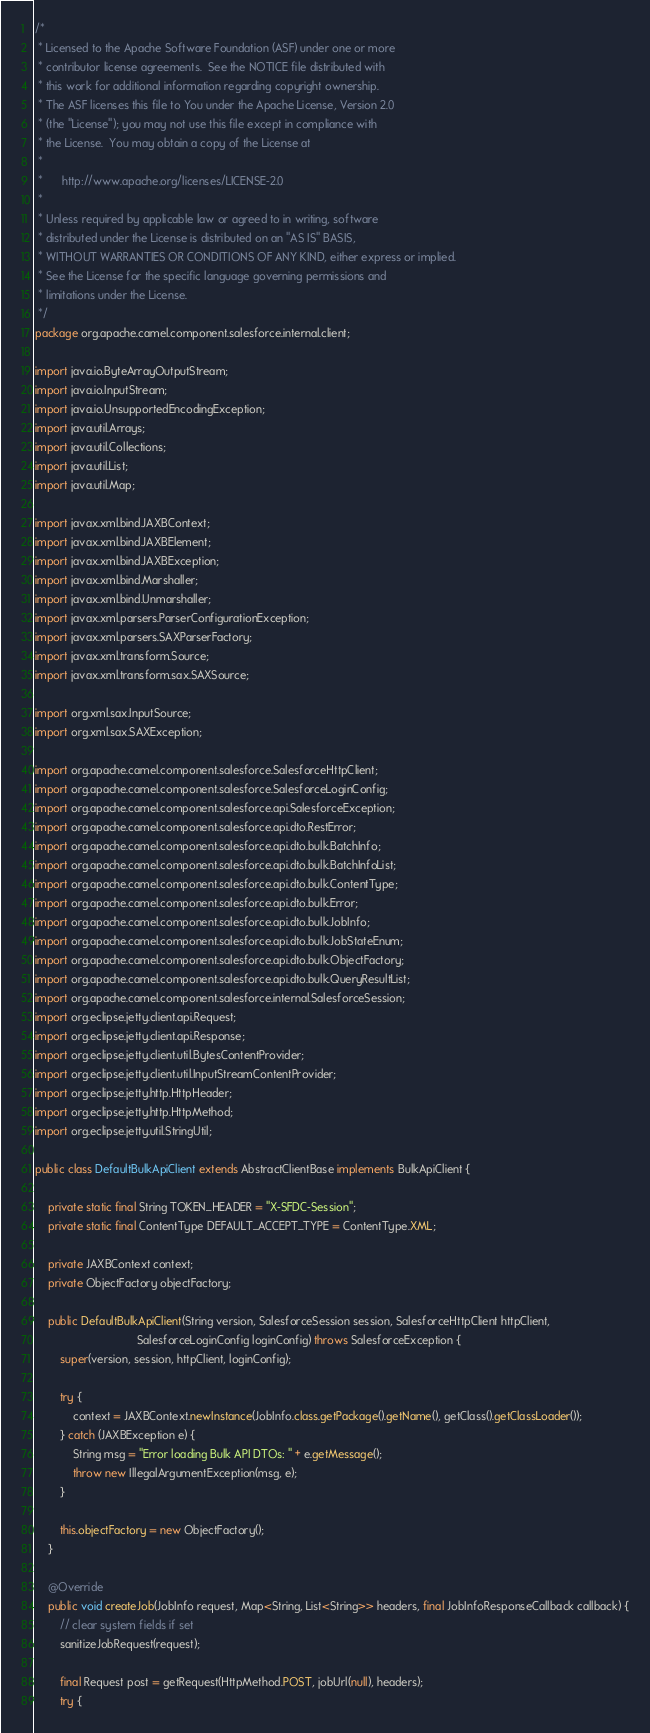<code> <loc_0><loc_0><loc_500><loc_500><_Java_>/*
 * Licensed to the Apache Software Foundation (ASF) under one or more
 * contributor license agreements.  See the NOTICE file distributed with
 * this work for additional information regarding copyright ownership.
 * The ASF licenses this file to You under the Apache License, Version 2.0
 * (the "License"); you may not use this file except in compliance with
 * the License.  You may obtain a copy of the License at
 *
 *      http://www.apache.org/licenses/LICENSE-2.0
 *
 * Unless required by applicable law or agreed to in writing, software
 * distributed under the License is distributed on an "AS IS" BASIS,
 * WITHOUT WARRANTIES OR CONDITIONS OF ANY KIND, either express or implied.
 * See the License for the specific language governing permissions and
 * limitations under the License.
 */
package org.apache.camel.component.salesforce.internal.client;

import java.io.ByteArrayOutputStream;
import java.io.InputStream;
import java.io.UnsupportedEncodingException;
import java.util.Arrays;
import java.util.Collections;
import java.util.List;
import java.util.Map;

import javax.xml.bind.JAXBContext;
import javax.xml.bind.JAXBElement;
import javax.xml.bind.JAXBException;
import javax.xml.bind.Marshaller;
import javax.xml.bind.Unmarshaller;
import javax.xml.parsers.ParserConfigurationException;
import javax.xml.parsers.SAXParserFactory;
import javax.xml.transform.Source;
import javax.xml.transform.sax.SAXSource;

import org.xml.sax.InputSource;
import org.xml.sax.SAXException;

import org.apache.camel.component.salesforce.SalesforceHttpClient;
import org.apache.camel.component.salesforce.SalesforceLoginConfig;
import org.apache.camel.component.salesforce.api.SalesforceException;
import org.apache.camel.component.salesforce.api.dto.RestError;
import org.apache.camel.component.salesforce.api.dto.bulk.BatchInfo;
import org.apache.camel.component.salesforce.api.dto.bulk.BatchInfoList;
import org.apache.camel.component.salesforce.api.dto.bulk.ContentType;
import org.apache.camel.component.salesforce.api.dto.bulk.Error;
import org.apache.camel.component.salesforce.api.dto.bulk.JobInfo;
import org.apache.camel.component.salesforce.api.dto.bulk.JobStateEnum;
import org.apache.camel.component.salesforce.api.dto.bulk.ObjectFactory;
import org.apache.camel.component.salesforce.api.dto.bulk.QueryResultList;
import org.apache.camel.component.salesforce.internal.SalesforceSession;
import org.eclipse.jetty.client.api.Request;
import org.eclipse.jetty.client.api.Response;
import org.eclipse.jetty.client.util.BytesContentProvider;
import org.eclipse.jetty.client.util.InputStreamContentProvider;
import org.eclipse.jetty.http.HttpHeader;
import org.eclipse.jetty.http.HttpMethod;
import org.eclipse.jetty.util.StringUtil;

public class DefaultBulkApiClient extends AbstractClientBase implements BulkApiClient {

    private static final String TOKEN_HEADER = "X-SFDC-Session";
    private static final ContentType DEFAULT_ACCEPT_TYPE = ContentType.XML;

    private JAXBContext context;
    private ObjectFactory objectFactory;

    public DefaultBulkApiClient(String version, SalesforceSession session, SalesforceHttpClient httpClient,
                                SalesforceLoginConfig loginConfig) throws SalesforceException {
        super(version, session, httpClient, loginConfig);

        try {
            context = JAXBContext.newInstance(JobInfo.class.getPackage().getName(), getClass().getClassLoader());
        } catch (JAXBException e) {
            String msg = "Error loading Bulk API DTOs: " + e.getMessage();
            throw new IllegalArgumentException(msg, e);
        }

        this.objectFactory = new ObjectFactory();
    }

    @Override
    public void createJob(JobInfo request, Map<String, List<String>> headers, final JobInfoResponseCallback callback) {
        // clear system fields if set
        sanitizeJobRequest(request);

        final Request post = getRequest(HttpMethod.POST, jobUrl(null), headers);
        try {</code> 